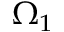<formula> <loc_0><loc_0><loc_500><loc_500>\Omega _ { 1 }</formula> 